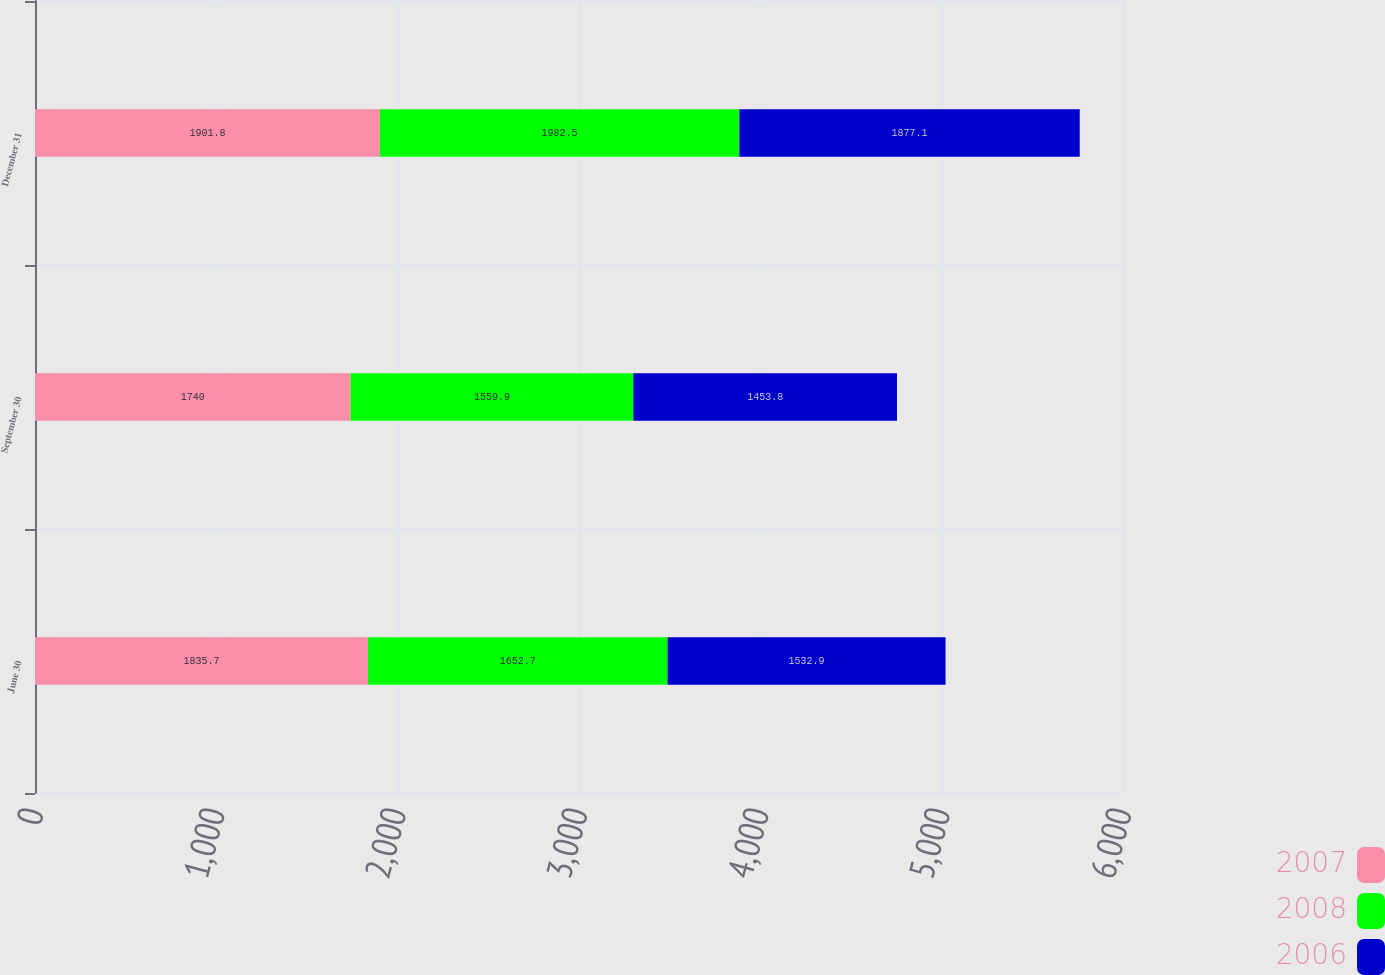Convert chart. <chart><loc_0><loc_0><loc_500><loc_500><stacked_bar_chart><ecel><fcel>June 30<fcel>September 30<fcel>December 31<nl><fcel>2007<fcel>1835.7<fcel>1740<fcel>1901.8<nl><fcel>2008<fcel>1652.7<fcel>1559.9<fcel>1982.5<nl><fcel>2006<fcel>1532.9<fcel>1453.8<fcel>1877.1<nl></chart> 